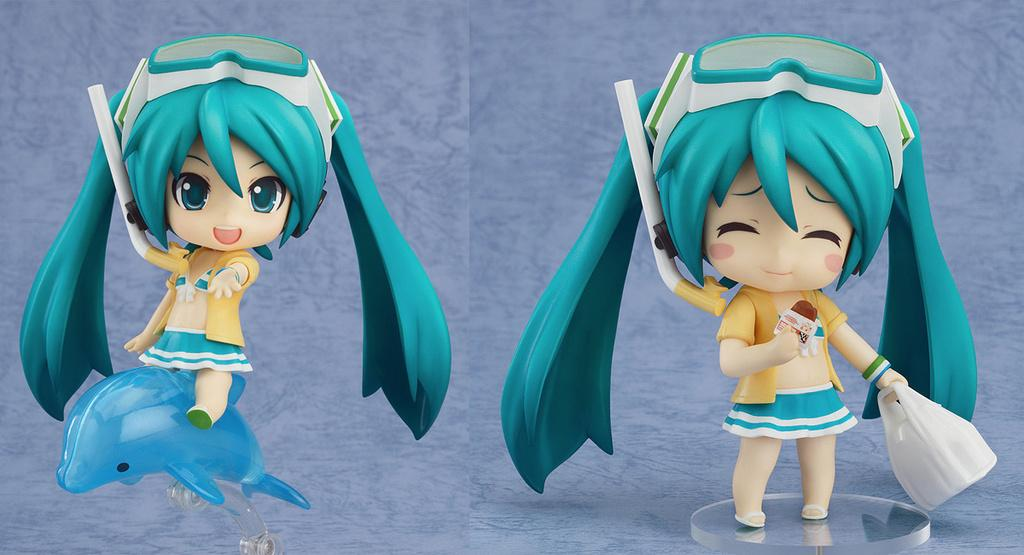What type of artwork is depicted in the image? The image is a collage. What objects can be seen in the collage? There are dolls in the collage. What is the expression on the doll's face in the downtown area of the image? There is no downtown area or doll's face present in the image, as it is a collage featuring dolls but does not depict a specific location or facial expressions. 